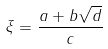<formula> <loc_0><loc_0><loc_500><loc_500>\xi = \frac { a + b \sqrt { d } } { c }</formula> 